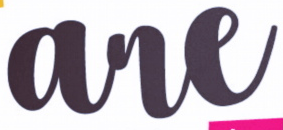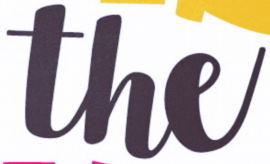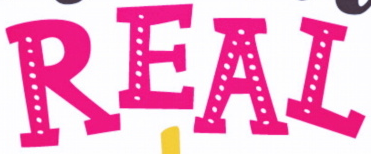Identify the words shown in these images in order, separated by a semicolon. are; the; REAL 